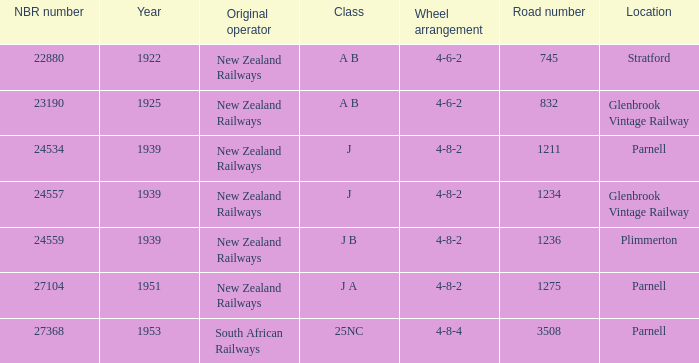Which original operator is in the 25nc class? South African Railways. 